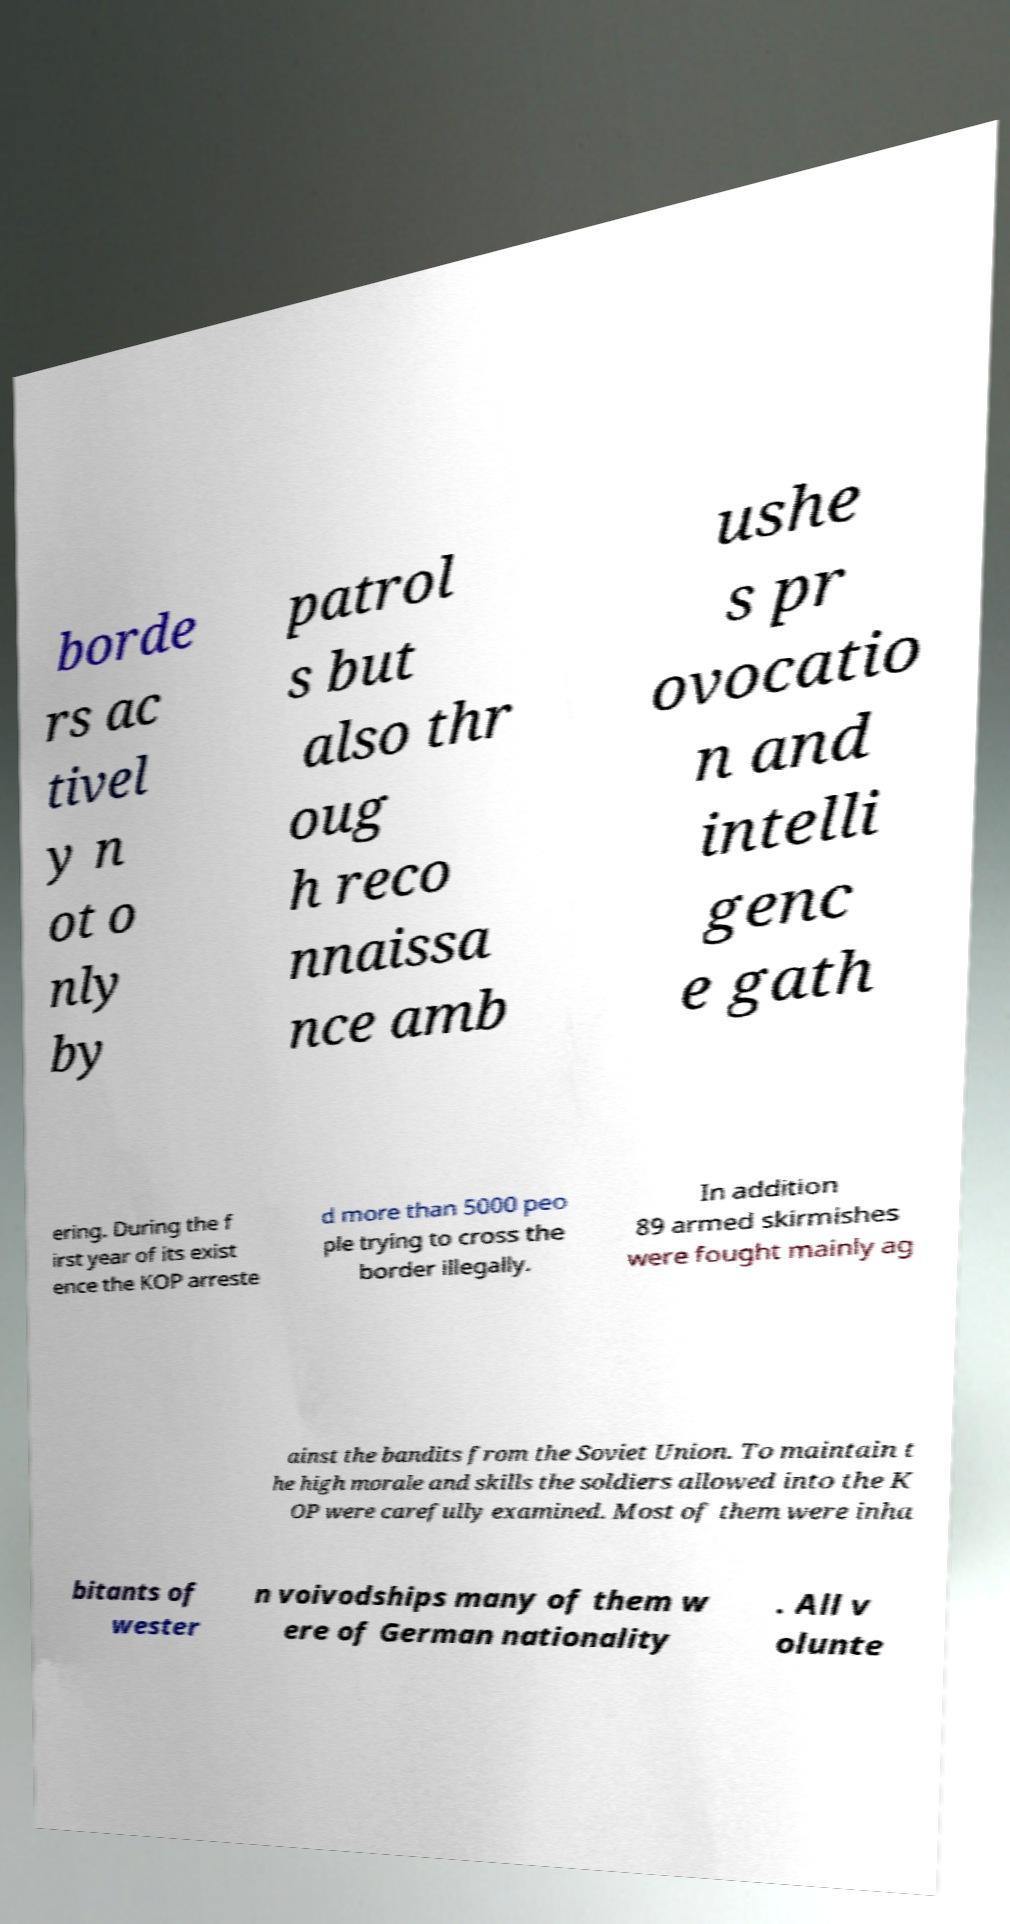What messages or text are displayed in this image? I need them in a readable, typed format. borde rs ac tivel y n ot o nly by patrol s but also thr oug h reco nnaissa nce amb ushe s pr ovocatio n and intelli genc e gath ering. During the f irst year of its exist ence the KOP arreste d more than 5000 peo ple trying to cross the border illegally. In addition 89 armed skirmishes were fought mainly ag ainst the bandits from the Soviet Union. To maintain t he high morale and skills the soldiers allowed into the K OP were carefully examined. Most of them were inha bitants of wester n voivodships many of them w ere of German nationality . All v olunte 